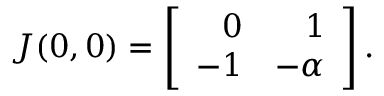<formula> <loc_0><loc_0><loc_500><loc_500>J ( 0 , 0 ) = \left [ { \begin{array} { r r } { 0 } & { 1 } \\ { - 1 } & { - \alpha } \end{array} } \right ] .</formula> 